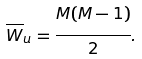<formula> <loc_0><loc_0><loc_500><loc_500>\overline { W } _ { u } = \cfrac { M ( M - 1 ) } { 2 } .</formula> 